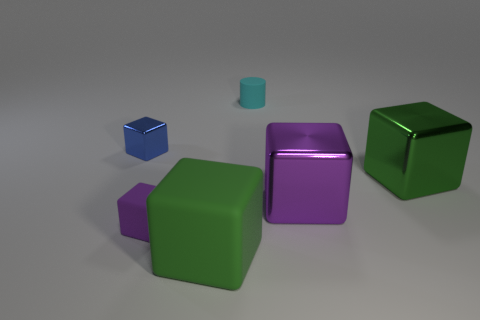Is the size of the green cube in front of the small purple rubber thing the same as the block that is behind the large green shiny thing?
Give a very brief answer. No. Is the number of purple matte cubes that are in front of the tiny blue metal object greater than the number of big green cubes that are on the right side of the big green rubber cube?
Your answer should be compact. No. What number of large yellow objects have the same shape as the small blue shiny thing?
Your answer should be compact. 0. There is a cylinder that is the same size as the blue block; what material is it?
Keep it short and to the point. Rubber. Is there a cube made of the same material as the small purple object?
Your answer should be very brief. Yes. Are there fewer small cyan rubber cylinders that are left of the green matte thing than green matte blocks?
Provide a short and direct response. Yes. The large green cube in front of the large green object behind the purple rubber object is made of what material?
Keep it short and to the point. Rubber. What shape is the small object that is both behind the small purple block and to the right of the tiny blue metal cube?
Ensure brevity in your answer.  Cylinder. What number of other things are the same color as the large matte thing?
Provide a succinct answer. 1. How many things are either small matte objects on the left side of the small cyan thing or small purple metallic cylinders?
Give a very brief answer. 1. 